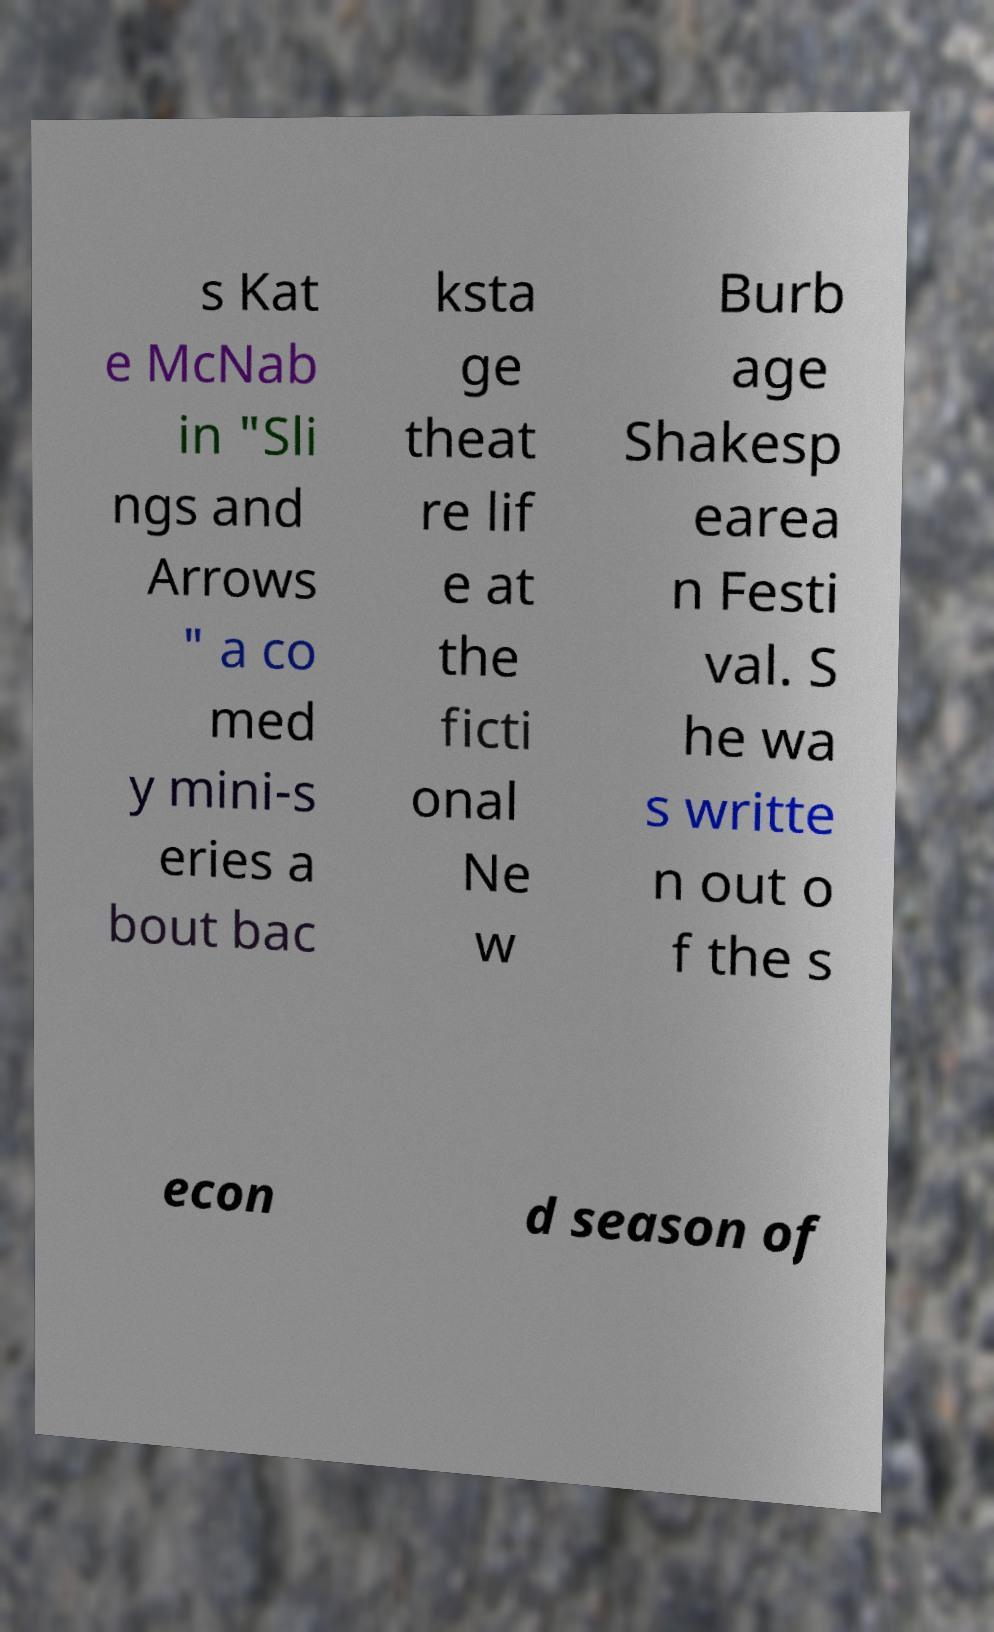Could you assist in decoding the text presented in this image and type it out clearly? s Kat e McNab in "Sli ngs and Arrows " a co med y mini-s eries a bout bac ksta ge theat re lif e at the ficti onal Ne w Burb age Shakesp earea n Festi val. S he wa s writte n out o f the s econ d season of 